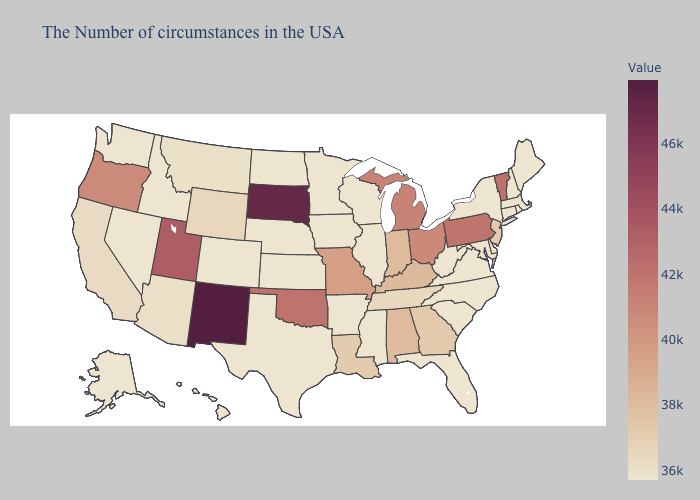Among the states that border Iowa , which have the highest value?
Concise answer only. South Dakota. Does Massachusetts have a higher value than Alabama?
Quick response, please. No. Among the states that border New Hampshire , which have the highest value?
Concise answer only. Vermont. 